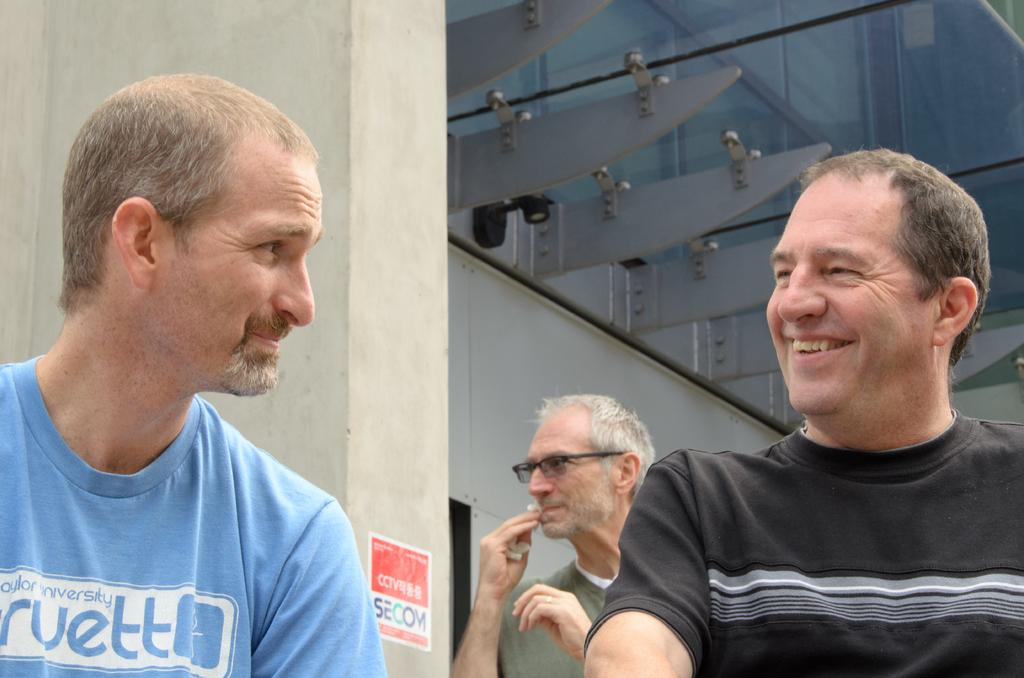How many people are in the image? There are three persons in the image. What are the persons wearing? The persons are wearing clothes. What can be seen in the background of the image? There is a wall in the background of the image. What type of sense can be seen in the image? There is no sense visible in the image; it features three persons and a wall in the background. How many ducks are present in the image? There are no ducks present in the image. 